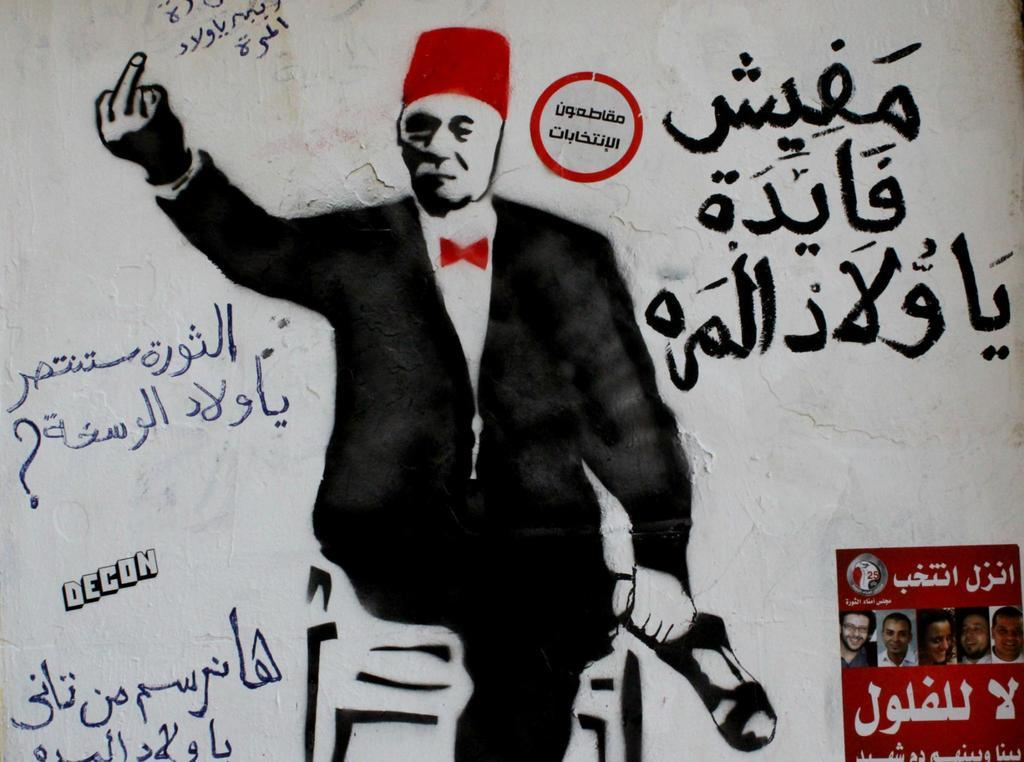What is depicted on the painting that is on the wall? There is a painting of a person on the wall. What else can be seen on the wall besides the painting? There are texts written on the wall and two posters on the wall. How many rabbits can be seen playing in the camp through the window in the image? There is no window, camp, or rabbits present in the image. 